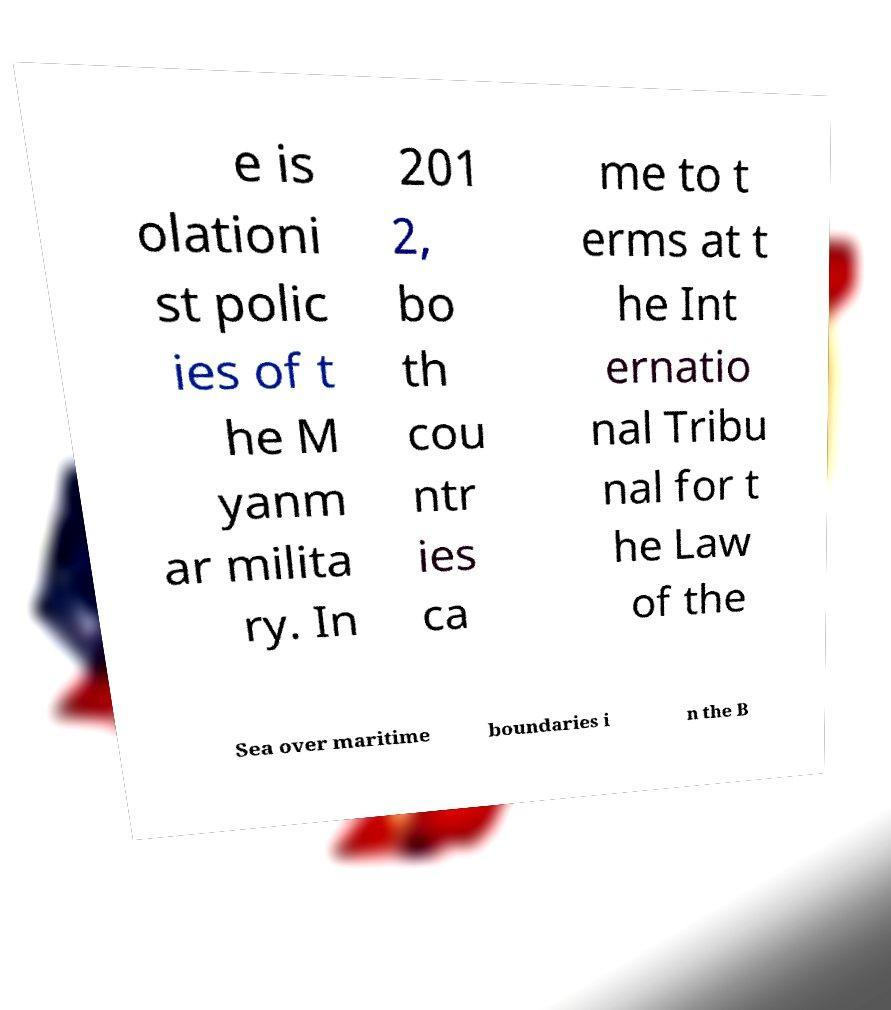What messages or text are displayed in this image? I need them in a readable, typed format. e is olationi st polic ies of t he M yanm ar milita ry. In 201 2, bo th cou ntr ies ca me to t erms at t he Int ernatio nal Tribu nal for t he Law of the Sea over maritime boundaries i n the B 